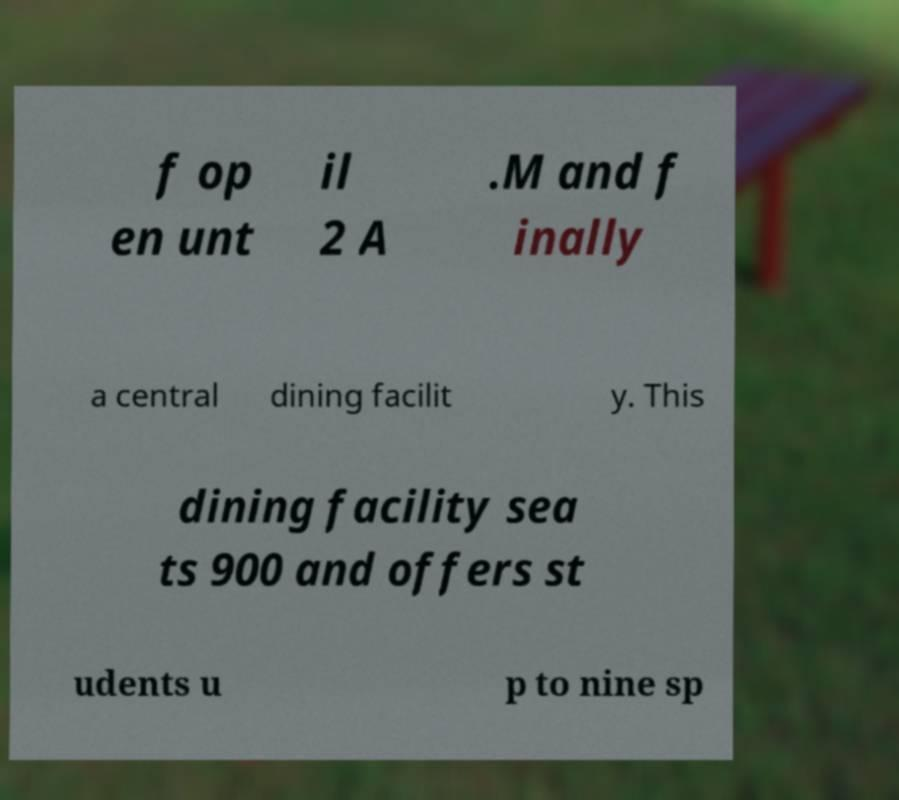Can you accurately transcribe the text from the provided image for me? f op en unt il 2 A .M and f inally a central dining facilit y. This dining facility sea ts 900 and offers st udents u p to nine sp 